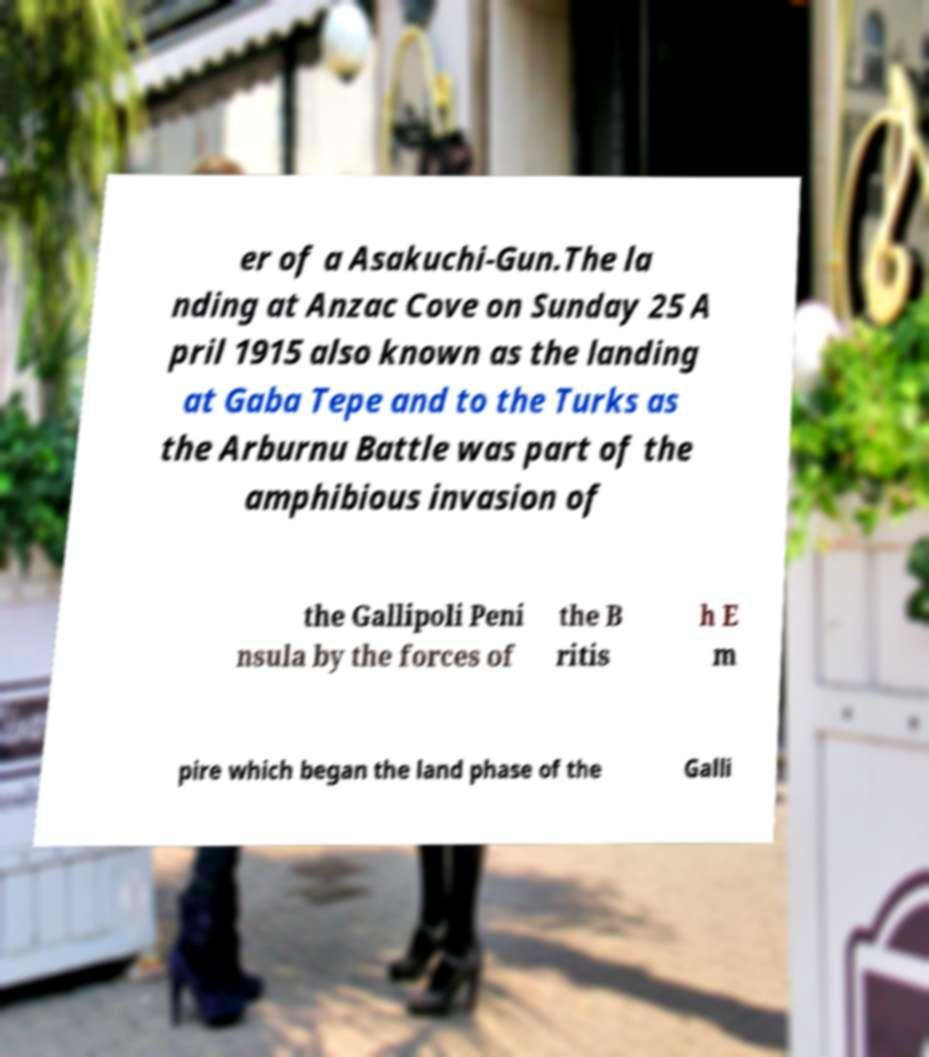Could you extract and type out the text from this image? er of a Asakuchi-Gun.The la nding at Anzac Cove on Sunday 25 A pril 1915 also known as the landing at Gaba Tepe and to the Turks as the Arburnu Battle was part of the amphibious invasion of the Gallipoli Peni nsula by the forces of the B ritis h E m pire which began the land phase of the Galli 